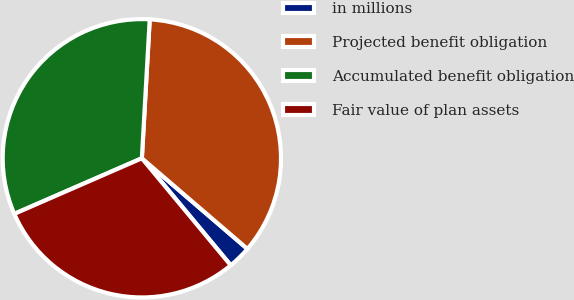Convert chart to OTSL. <chart><loc_0><loc_0><loc_500><loc_500><pie_chart><fcel>in millions<fcel>Projected benefit obligation<fcel>Accumulated benefit obligation<fcel>Fair value of plan assets<nl><fcel>2.68%<fcel>35.39%<fcel>32.44%<fcel>29.49%<nl></chart> 